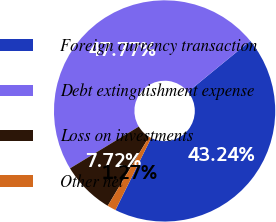Convert chart to OTSL. <chart><loc_0><loc_0><loc_500><loc_500><pie_chart><fcel>Foreign currency transaction<fcel>Debt extinguishment expense<fcel>Loss on investments<fcel>Other net<nl><fcel>43.24%<fcel>47.77%<fcel>7.72%<fcel>1.27%<nl></chart> 